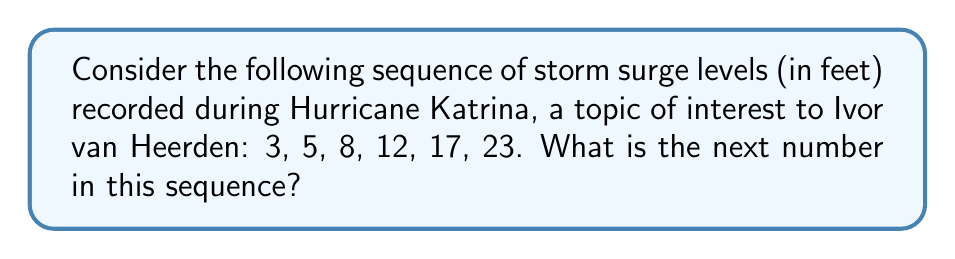Can you answer this question? To solve this problem, let's follow these steps:

1) First, we need to identify the pattern in the sequence. Let's calculate the differences between consecutive terms:

   $5 - 3 = 2$
   $8 - 5 = 3$
   $12 - 8 = 4$
   $17 - 12 = 5$
   $23 - 17 = 6$

2) We can see that the differences are increasing by 1 each time: 2, 3, 4, 5, 6.

3) This suggests that the sequence follows a quadratic pattern, where the second differences are constant.

4) To confirm this, let's calculate the second differences:

   $3 - 2 = 1$
   $4 - 3 = 1$
   $5 - 4 = 1$
   $6 - 5 = 1$

5) Indeed, the second differences are constant (1), confirming a quadratic sequence.

6) For a quadratic sequence, we can use the formula:
   
   $a_n = \frac{1}{2}n^2 + bn + c$

   where $n$ is the term number (starting from 0), and $a$, $b$, and $c$ are constants we need to determine.

7) Using the first three terms of the sequence, we can set up a system of equations:

   $3 = \frac{1}{2}(0)^2 + b(0) + c$
   $5 = \frac{1}{2}(1)^2 + b(1) + c$
   $8 = \frac{1}{2}(2)^2 + b(2) + c$

8) Solving this system, we get:
   
   $a_n = \frac{1}{2}n^2 + \frac{3}{2}n + 3$

9) To find the next term, we need to calculate $a_6$ (since we already have 6 terms):

   $a_6 = \frac{1}{2}(6)^2 + \frac{3}{2}(6) + 3 = 18 + 9 + 3 = 30$

Therefore, the next number in the sequence is 30.
Answer: 30 